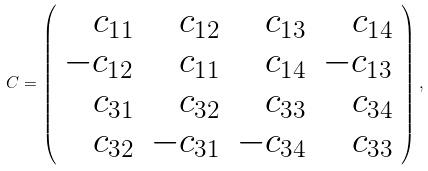<formula> <loc_0><loc_0><loc_500><loc_500>C = \left ( \begin{array} { r r r r } c _ { 1 1 } & c _ { 1 2 } & c _ { 1 3 } & c _ { 1 4 } \\ - c _ { 1 2 } & c _ { 1 1 } & c _ { 1 4 } & - c _ { 1 3 } \\ c _ { 3 1 } & c _ { 3 2 } & c _ { 3 3 } & c _ { 3 4 } \\ c _ { 3 2 } & - c _ { 3 1 } & - c _ { 3 4 } & c _ { 3 3 } \end{array} \right ) ,</formula> 